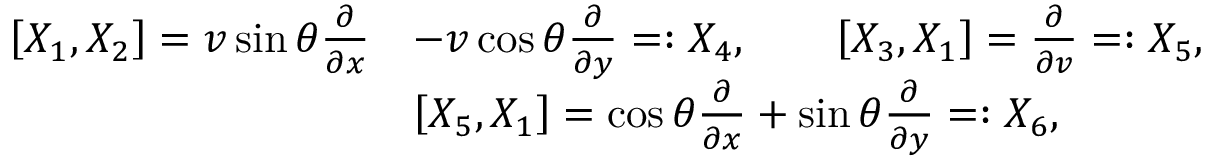<formula> <loc_0><loc_0><loc_500><loc_500>\begin{array} { r l } { \left [ X _ { 1 } , X _ { 2 } \right ] = v \sin \theta \frac { \partial } { \partial { x } } } & { - v \cos \theta \frac { \partial } { \partial { y } } = \colon X _ { 4 } , \quad \left [ X _ { 3 } , X _ { 1 } \right ] = \frac { \partial } { \partial { v } } = \colon X _ { 5 } , } \\ & { \left [ X _ { 5 } , X _ { 1 } \right ] = \cos \theta \frac { \partial } { \partial { x } } + \sin \theta \frac { \partial } { \partial { y } } = \colon X _ { 6 } , } \end{array}</formula> 